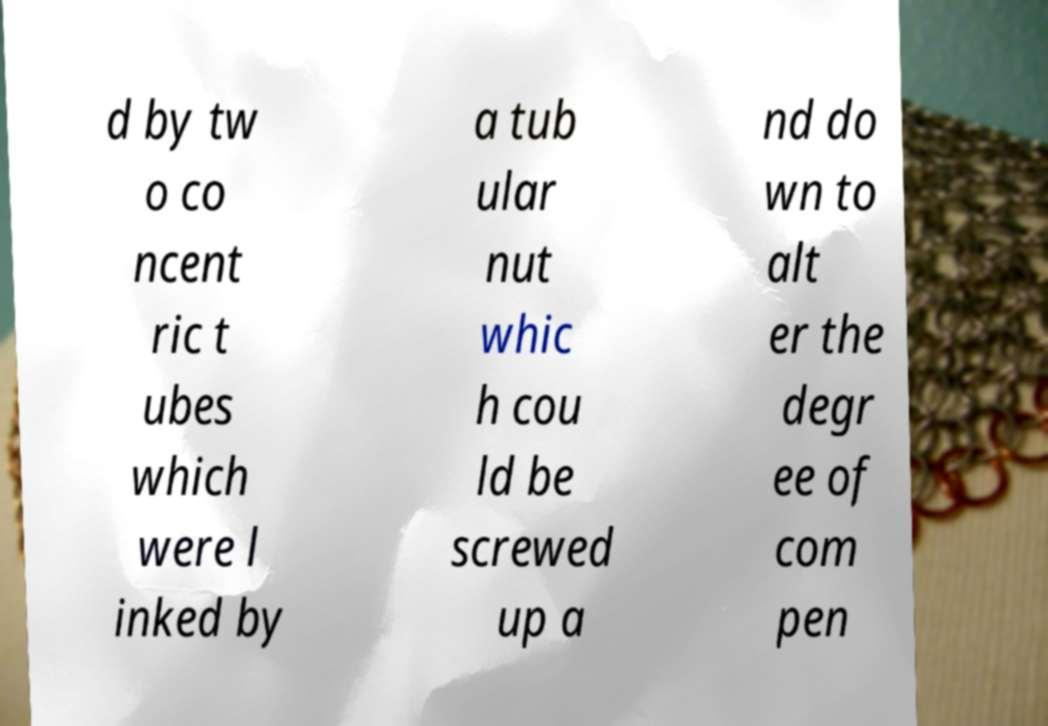Can you read and provide the text displayed in the image?This photo seems to have some interesting text. Can you extract and type it out for me? d by tw o co ncent ric t ubes which were l inked by a tub ular nut whic h cou ld be screwed up a nd do wn to alt er the degr ee of com pen 